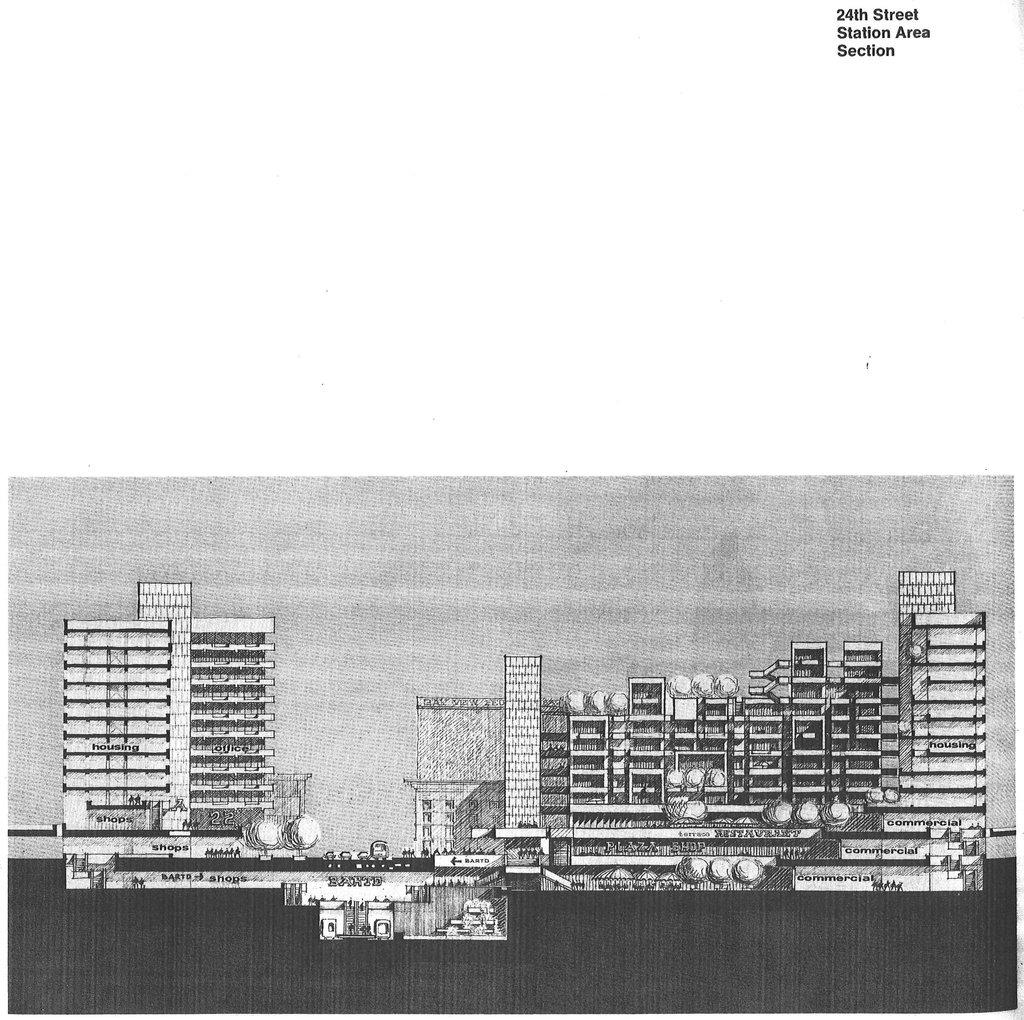What is the color scheme of the image? The image is black and white. What is the main subject of the image? There is a picture of buildings in the image. What is the chance of winning a prize in the image? There is no indication of a prize or chance of winning in the image, as it only features a black and white picture of buildings. Can you see an elbow in the image? There is no elbow visible in the image, as it only features a picture of buildings. 